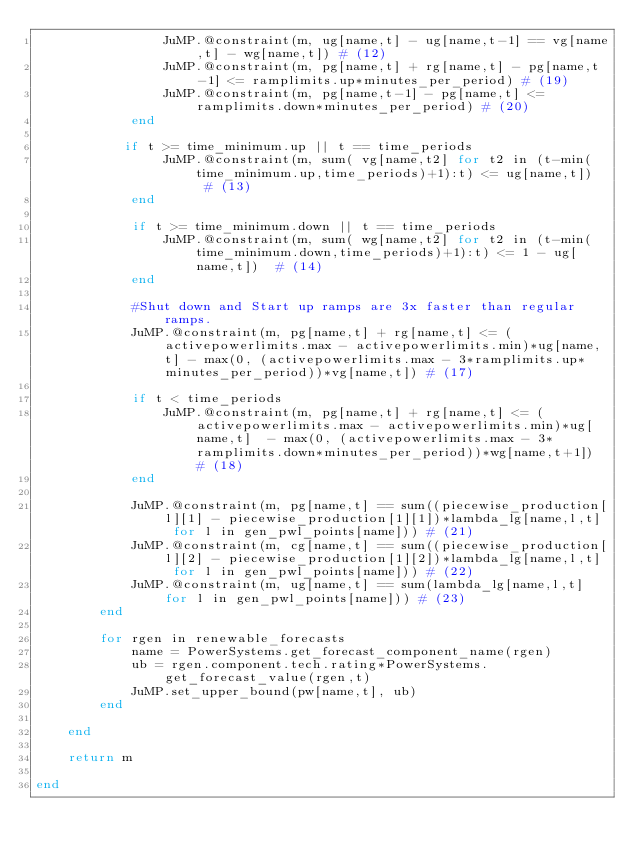<code> <loc_0><loc_0><loc_500><loc_500><_Julia_>                JuMP.@constraint(m, ug[name,t] - ug[name,t-1] == vg[name,t] - wg[name,t]) # (12)
                JuMP.@constraint(m, pg[name,t] + rg[name,t] - pg[name,t-1] <= ramplimits.up*minutes_per_period) # (19)
                JuMP.@constraint(m, pg[name,t-1] - pg[name,t] <= ramplimits.down*minutes_per_period) # (20)
            end

           if t >= time_minimum.up || t == time_periods
                JuMP.@constraint(m, sum( vg[name,t2] for t2 in (t-min(time_minimum.up,time_periods)+1):t) <= ug[name,t])  # (13)
            end

            if t >= time_minimum.down || t == time_periods
                JuMP.@constraint(m, sum( wg[name,t2] for t2 in (t-min(time_minimum.down,time_periods)+1):t) <= 1 - ug[name,t])  # (14)
            end

            #Shut down and Start up ramps are 3x faster than regular ramps.
            JuMP.@constraint(m, pg[name,t] + rg[name,t] <= (activepowerlimits.max - activepowerlimits.min)*ug[name,t] - max(0, (activepowerlimits.max - 3*ramplimits.up*minutes_per_period))*vg[name,t]) # (17)

            if t < time_periods
                JuMP.@constraint(m, pg[name,t] + rg[name,t] <= (activepowerlimits.max - activepowerlimits.min)*ug[name,t]  - max(0, (activepowerlimits.max - 3*ramplimits.down*minutes_per_period))*wg[name,t+1]) # (18)
            end

            JuMP.@constraint(m, pg[name,t] == sum((piecewise_production[l][1] - piecewise_production[1][1])*lambda_lg[name,l,t] for l in gen_pwl_points[name])) # (21)
            JuMP.@constraint(m, cg[name,t] == sum((piecewise_production[l][2] - piecewise_production[1][2])*lambda_lg[name,l,t] for l in gen_pwl_points[name])) # (22)
            JuMP.@constraint(m, ug[name,t] == sum(lambda_lg[name,l,t] for l in gen_pwl_points[name])) # (23)
        end

        for rgen in renewable_forecasts
            name = PowerSystems.get_forecast_component_name(rgen)
            ub = rgen.component.tech.rating*PowerSystems.get_forecast_value(rgen,t)
            JuMP.set_upper_bound(pw[name,t], ub)
        end

    end

    return m

end
</code> 